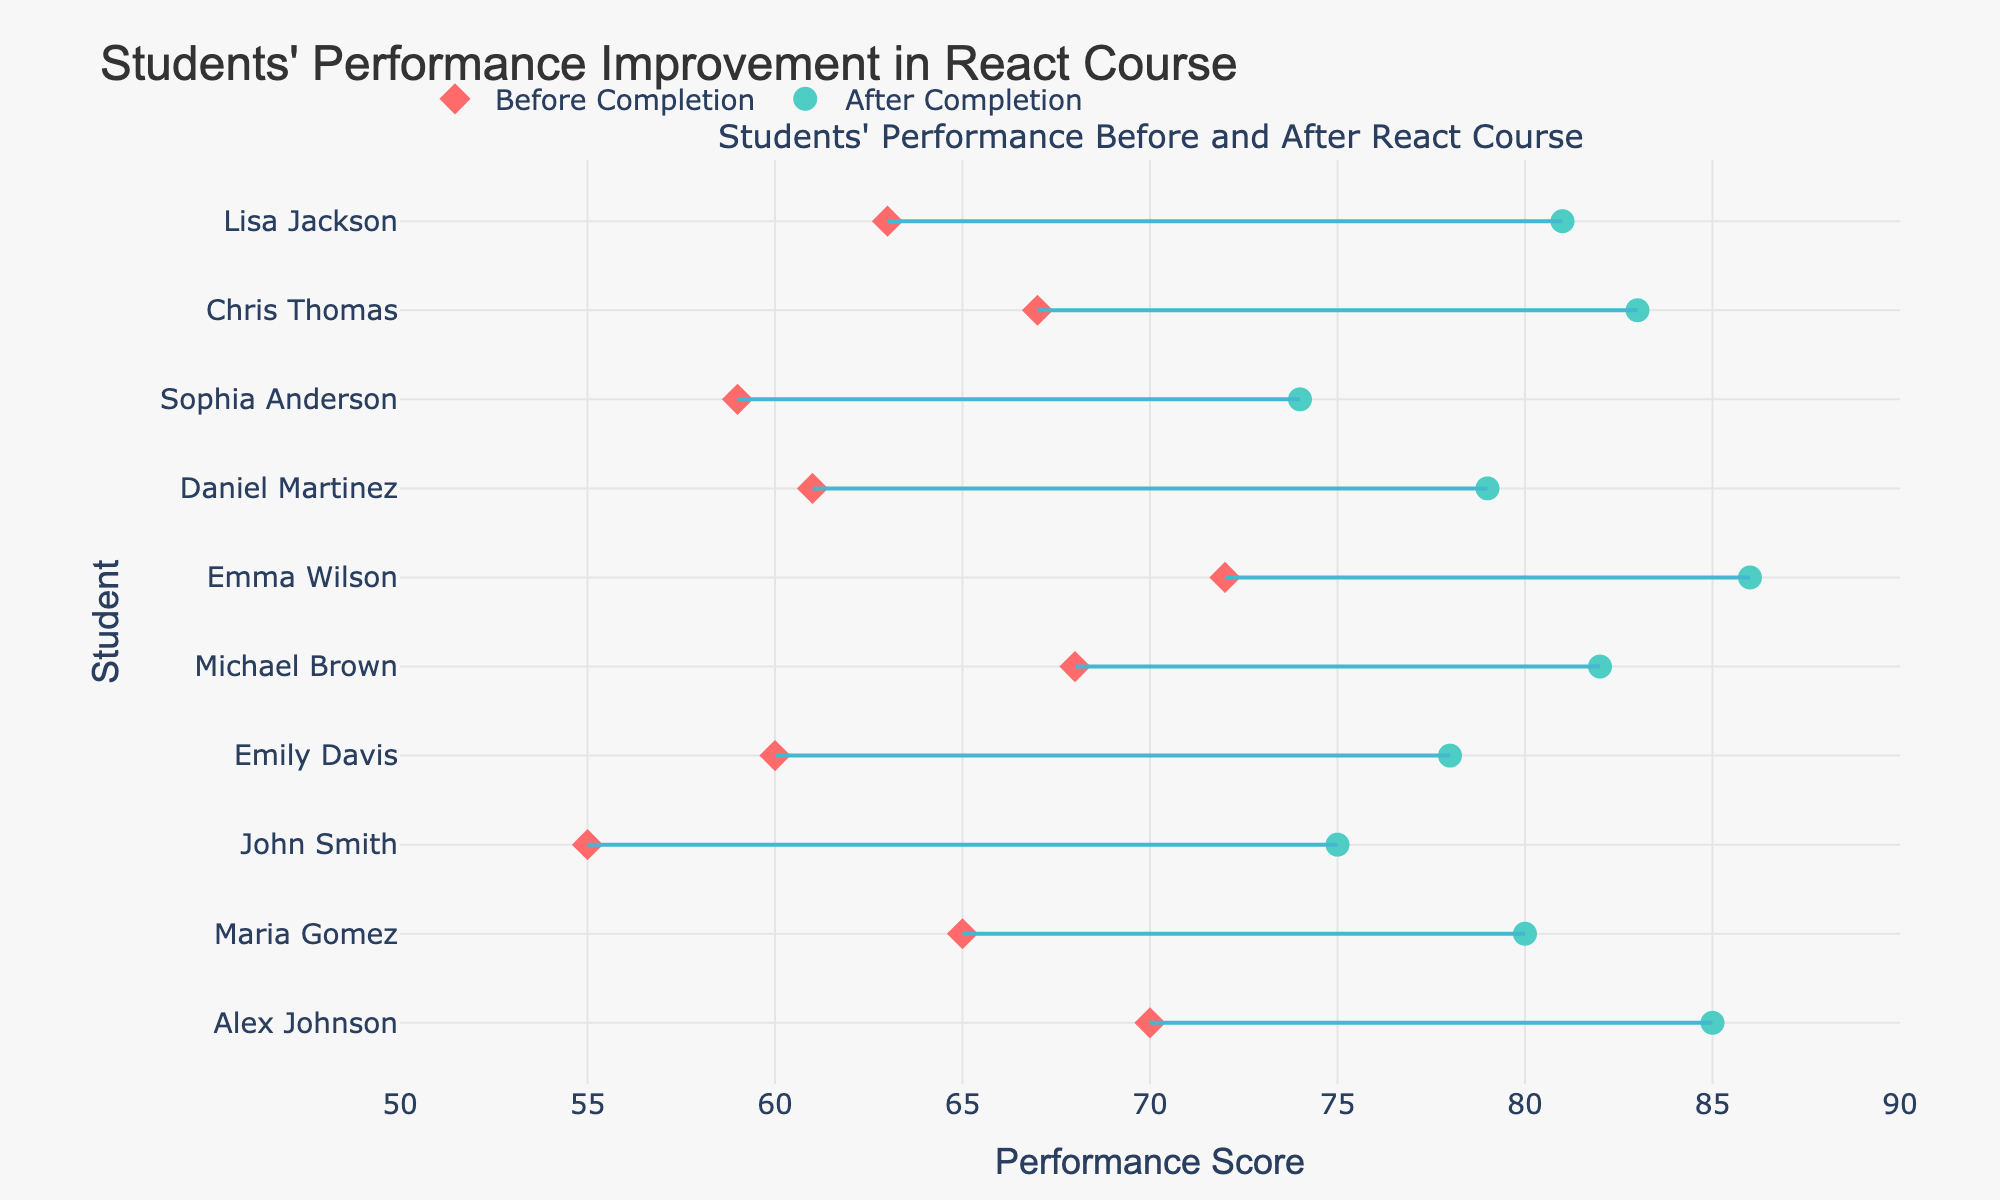What’s the title of the plot? The title is the largest text at the top of the visual, written in bold, usually providing a summary for the entire figure. Here, it reads "Students' Performance Improvement in React Course".
Answer: Students' Performance Improvement in React Course How many students' performances are shown in the plot? The plot has markers (diamonds and circles) representing individual students. Counting these markers can tell the number of students. In this case, we have data points for 10 students.
Answer: 10 Which student scored the highest after completing the React course? For identifying the highest score after completion, look at the positions of the circles (representing after completion scores) on the x-axis. Emma Wilson has the highest score with 86 points.
Answer: Emma Wilson What is the range of performance scores before the course? To find the range, observe the minimum and maximum positions of the diamond markers. The scores range from 55 (John Smith) to 72 (Emma Wilson).
Answer: 55 to 72 Which student showed the greatest improvement after completing the React course? Compute the difference between 'After Completion' and 'Before Completion' for each student and identify the maximum. John Smith improved from 55 to 75, a total of 20 points, which is the highest improvement.
Answer: John Smith On average, how much did students' scores increase after completing the course? Calculate the difference in scores for each student, sum them, and divide by the number of students. Differences are: 15, 15, 20, 18, 14, 14, 18, 15, 16, and 18. The total is 163, and the average is 163/10 = 16.3.
Answer: 16.3 points Who had a score less than 60 before the course and what was their score after completion? Identify the student(s) with a 'Before Completion' score less than 60, then check their 'After Completion' scores. John Smith and Sophia Anderson had scores of 55 and 59 before the course, and 75 and 74 after.
Answer: John Smith (75), Sophia Anderson (74) What color represents the scores after course completion? Observing the plot, the markers (circles) representing 'After Completion' are colored in a light teal/cyan color.
Answer: Light teal/cyan Which student has scores that fall between 70 and 80 after completing the course? Check the circles that fall within the range of 70 to 80 on the x-axis. Maria Gomez and Emily Davis both have scores in this range: 80 and 78, respectively.
Answer: Maria Gomez (80), Emily Davis (78) Compare the scores of Alex Johnson before and after the React course and state the improvement. Alex Johnson's score before the course was 70 and improved to 85 after. The improvement is calculated by finding the difference: 85 - 70 = 15.
Answer: Improved by 15 points 